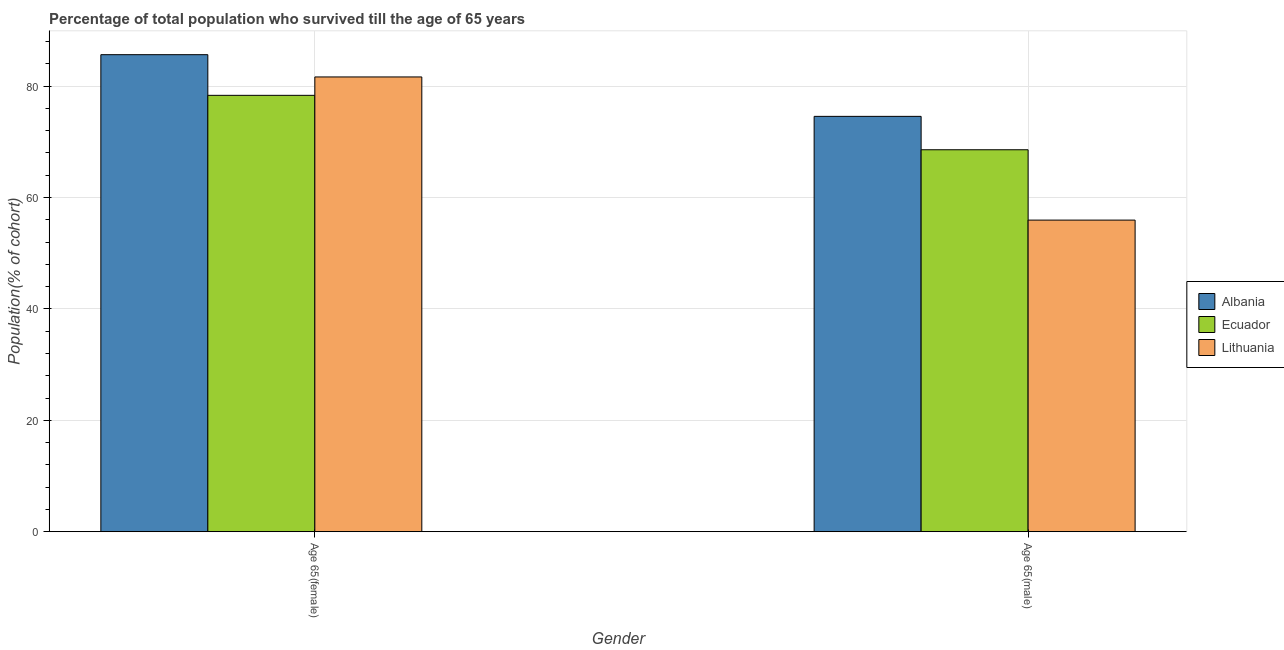How many different coloured bars are there?
Provide a succinct answer. 3. Are the number of bars on each tick of the X-axis equal?
Give a very brief answer. Yes. How many bars are there on the 2nd tick from the right?
Keep it short and to the point. 3. What is the label of the 2nd group of bars from the left?
Your answer should be compact. Age 65(male). What is the percentage of male population who survived till age of 65 in Lithuania?
Your response must be concise. 55.95. Across all countries, what is the maximum percentage of female population who survived till age of 65?
Give a very brief answer. 85.65. Across all countries, what is the minimum percentage of male population who survived till age of 65?
Provide a succinct answer. 55.95. In which country was the percentage of male population who survived till age of 65 maximum?
Your response must be concise. Albania. In which country was the percentage of male population who survived till age of 65 minimum?
Ensure brevity in your answer.  Lithuania. What is the total percentage of male population who survived till age of 65 in the graph?
Ensure brevity in your answer.  199.1. What is the difference between the percentage of female population who survived till age of 65 in Ecuador and that in Albania?
Ensure brevity in your answer.  -7.3. What is the difference between the percentage of female population who survived till age of 65 in Ecuador and the percentage of male population who survived till age of 65 in Albania?
Offer a terse response. 3.78. What is the average percentage of male population who survived till age of 65 per country?
Give a very brief answer. 66.37. What is the difference between the percentage of female population who survived till age of 65 and percentage of male population who survived till age of 65 in Albania?
Your answer should be very brief. 11.08. In how many countries, is the percentage of male population who survived till age of 65 greater than 40 %?
Ensure brevity in your answer.  3. What is the ratio of the percentage of male population who survived till age of 65 in Ecuador to that in Lithuania?
Offer a terse response. 1.23. Is the percentage of female population who survived till age of 65 in Albania less than that in Ecuador?
Give a very brief answer. No. In how many countries, is the percentage of male population who survived till age of 65 greater than the average percentage of male population who survived till age of 65 taken over all countries?
Your response must be concise. 2. What does the 3rd bar from the left in Age 65(female) represents?
Ensure brevity in your answer.  Lithuania. What does the 2nd bar from the right in Age 65(female) represents?
Keep it short and to the point. Ecuador. Are all the bars in the graph horizontal?
Give a very brief answer. No. How many countries are there in the graph?
Offer a very short reply. 3. What is the difference between two consecutive major ticks on the Y-axis?
Your response must be concise. 20. Are the values on the major ticks of Y-axis written in scientific E-notation?
Make the answer very short. No. Does the graph contain any zero values?
Your answer should be very brief. No. Where does the legend appear in the graph?
Your answer should be compact. Center right. What is the title of the graph?
Ensure brevity in your answer.  Percentage of total population who survived till the age of 65 years. What is the label or title of the X-axis?
Your response must be concise. Gender. What is the label or title of the Y-axis?
Make the answer very short. Population(% of cohort). What is the Population(% of cohort) in Albania in Age 65(female)?
Keep it short and to the point. 85.65. What is the Population(% of cohort) in Ecuador in Age 65(female)?
Keep it short and to the point. 78.35. What is the Population(% of cohort) in Lithuania in Age 65(female)?
Make the answer very short. 81.65. What is the Population(% of cohort) of Albania in Age 65(male)?
Offer a terse response. 74.57. What is the Population(% of cohort) of Ecuador in Age 65(male)?
Your response must be concise. 68.58. What is the Population(% of cohort) in Lithuania in Age 65(male)?
Provide a succinct answer. 55.95. Across all Gender, what is the maximum Population(% of cohort) of Albania?
Keep it short and to the point. 85.65. Across all Gender, what is the maximum Population(% of cohort) in Ecuador?
Keep it short and to the point. 78.35. Across all Gender, what is the maximum Population(% of cohort) of Lithuania?
Give a very brief answer. 81.65. Across all Gender, what is the minimum Population(% of cohort) of Albania?
Your response must be concise. 74.57. Across all Gender, what is the minimum Population(% of cohort) of Ecuador?
Offer a terse response. 68.58. Across all Gender, what is the minimum Population(% of cohort) of Lithuania?
Make the answer very short. 55.95. What is the total Population(% of cohort) in Albania in the graph?
Ensure brevity in your answer.  160.22. What is the total Population(% of cohort) of Ecuador in the graph?
Offer a very short reply. 146.93. What is the total Population(% of cohort) of Lithuania in the graph?
Your response must be concise. 137.6. What is the difference between the Population(% of cohort) in Albania in Age 65(female) and that in Age 65(male)?
Keep it short and to the point. 11.08. What is the difference between the Population(% of cohort) of Ecuador in Age 65(female) and that in Age 65(male)?
Make the answer very short. 9.77. What is the difference between the Population(% of cohort) of Lithuania in Age 65(female) and that in Age 65(male)?
Offer a very short reply. 25.7. What is the difference between the Population(% of cohort) in Albania in Age 65(female) and the Population(% of cohort) in Ecuador in Age 65(male)?
Give a very brief answer. 17.07. What is the difference between the Population(% of cohort) of Albania in Age 65(female) and the Population(% of cohort) of Lithuania in Age 65(male)?
Your answer should be compact. 29.7. What is the difference between the Population(% of cohort) of Ecuador in Age 65(female) and the Population(% of cohort) of Lithuania in Age 65(male)?
Make the answer very short. 22.4. What is the average Population(% of cohort) in Albania per Gender?
Provide a short and direct response. 80.11. What is the average Population(% of cohort) of Ecuador per Gender?
Ensure brevity in your answer.  73.46. What is the average Population(% of cohort) of Lithuania per Gender?
Provide a succinct answer. 68.8. What is the difference between the Population(% of cohort) of Albania and Population(% of cohort) of Ecuador in Age 65(female)?
Offer a terse response. 7.3. What is the difference between the Population(% of cohort) of Albania and Population(% of cohort) of Lithuania in Age 65(female)?
Your response must be concise. 4. What is the difference between the Population(% of cohort) in Ecuador and Population(% of cohort) in Lithuania in Age 65(female)?
Offer a very short reply. -3.3. What is the difference between the Population(% of cohort) in Albania and Population(% of cohort) in Ecuador in Age 65(male)?
Your answer should be compact. 6. What is the difference between the Population(% of cohort) of Albania and Population(% of cohort) of Lithuania in Age 65(male)?
Keep it short and to the point. 18.63. What is the difference between the Population(% of cohort) of Ecuador and Population(% of cohort) of Lithuania in Age 65(male)?
Provide a succinct answer. 12.63. What is the ratio of the Population(% of cohort) of Albania in Age 65(female) to that in Age 65(male)?
Your answer should be very brief. 1.15. What is the ratio of the Population(% of cohort) in Ecuador in Age 65(female) to that in Age 65(male)?
Your answer should be very brief. 1.14. What is the ratio of the Population(% of cohort) of Lithuania in Age 65(female) to that in Age 65(male)?
Offer a terse response. 1.46. What is the difference between the highest and the second highest Population(% of cohort) in Albania?
Ensure brevity in your answer.  11.08. What is the difference between the highest and the second highest Population(% of cohort) in Ecuador?
Your response must be concise. 9.77. What is the difference between the highest and the second highest Population(% of cohort) in Lithuania?
Ensure brevity in your answer.  25.7. What is the difference between the highest and the lowest Population(% of cohort) in Albania?
Make the answer very short. 11.08. What is the difference between the highest and the lowest Population(% of cohort) of Ecuador?
Your answer should be very brief. 9.77. What is the difference between the highest and the lowest Population(% of cohort) of Lithuania?
Your response must be concise. 25.7. 